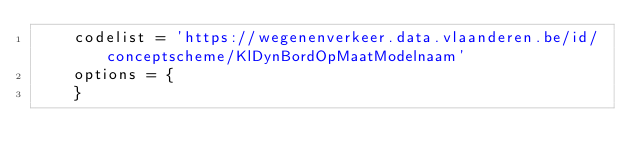<code> <loc_0><loc_0><loc_500><loc_500><_Python_>    codelist = 'https://wegenenverkeer.data.vlaanderen.be/id/conceptscheme/KlDynBordOpMaatModelnaam'
    options = {
    }

</code> 